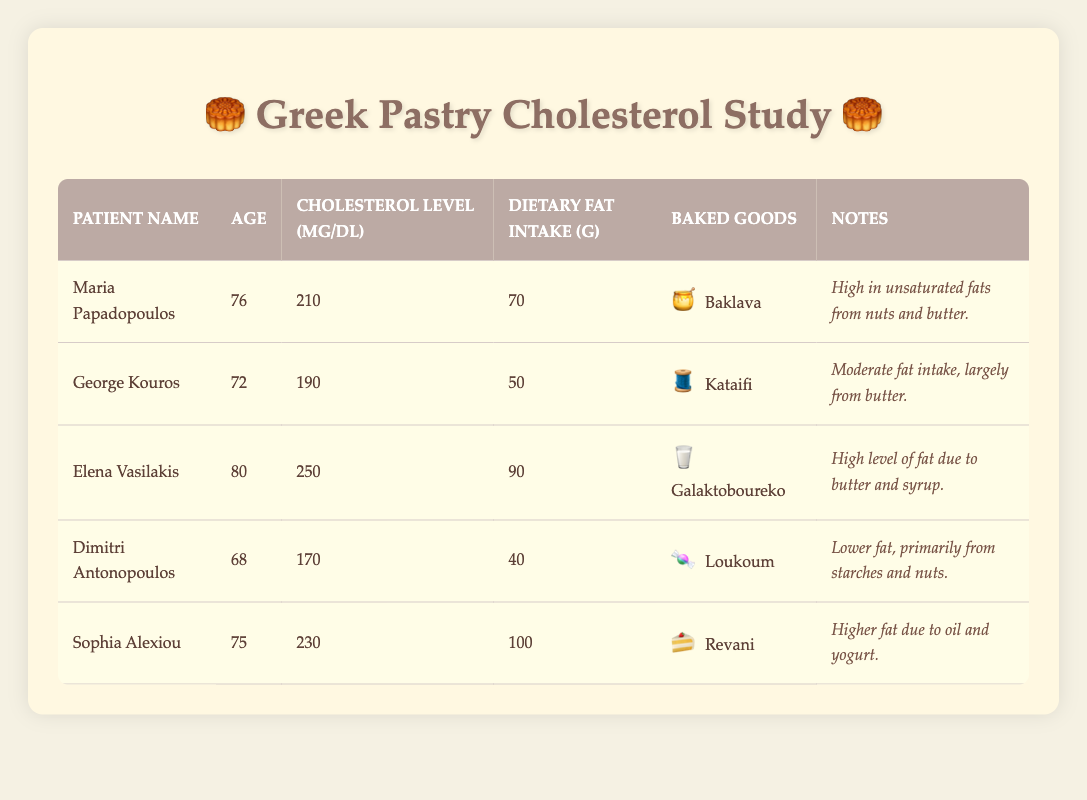What is the cholesterol level of Maria Papadopoulos? According to the table, the cholesterol level for Maria Papadopoulos is indicated in her row under the "Cholesterol Level (mg/dL)" column. It states that her cholesterol level is 210 mg/dL.
Answer: 210 mg/dL Which baked good has the highest dietary fat intake? To find this, we can look at the "Dietary Fat Intake (g)" column for each baked good. The highest value is for "Revani," which has a dietary fat intake of 100 g.
Answer: Revani Is Elena Vasilakis's cholesterol level above 240 mg/dL? In the table, Elena Vasilakis's cholesterol level is 250 mg/dL, which is indeed above 240 mg/dL. Thus, the answer is yes.
Answer: Yes What is the average dietary fat intake of the patients listed? We can find the average by first adding all the dietary fat intake values: 70 + 50 + 90 + 40 + 100 = 350 g. There are 5 patients, so we divide 350 by 5 to get the average, which is 70 g.
Answer: 70 g Do all patients have cholesterol levels above 180 mg/dL? We check each cholesterol level: Maria (210), George (190), Elena (250), Dimitri (170), and Sophia (230). Since Dimitri has a level of 170, not all patients exceed 180 mg/dL. Thus, the answer is no.
Answer: No Who has the lowest cholesterol level and what is that level? By reviewing the "Cholesterol Level (mg/dL)" column, we find Dimitri Antonopoulos with a cholesterol level of 170 mg/dL, which is the lowest among all listed.
Answer: Dimitri Antonopoulos, 170 mg/dL What percentage of patients have dietary fat intake above 75 g? Three patients (Maria with 70 g, Elena with 90 g, and Sophia with 100 g) have dietary fat intake above 75 g. This is 3 out of 5 patients. Therefore, (3/5) * 100 = 60%.
Answer: 60% Which patient has the baked good that is highest in fat content? The highest fat content based on the notes appears to be Galaktoboureko, associated with Elena Vasilakis, who has a dietary fat intake of 90 g.
Answer: Elena Vasilakis, Galaktoboureko What is the difference in cholesterol levels between the highest and lowest patients? The highest cholesterol level is Elena Vasilakis at 250 mg/dL and the lowest is Dimitri Antonopoulos at 170 mg/dL. The difference is 250 - 170 = 80 mg/dL.
Answer: 80 mg/dL 